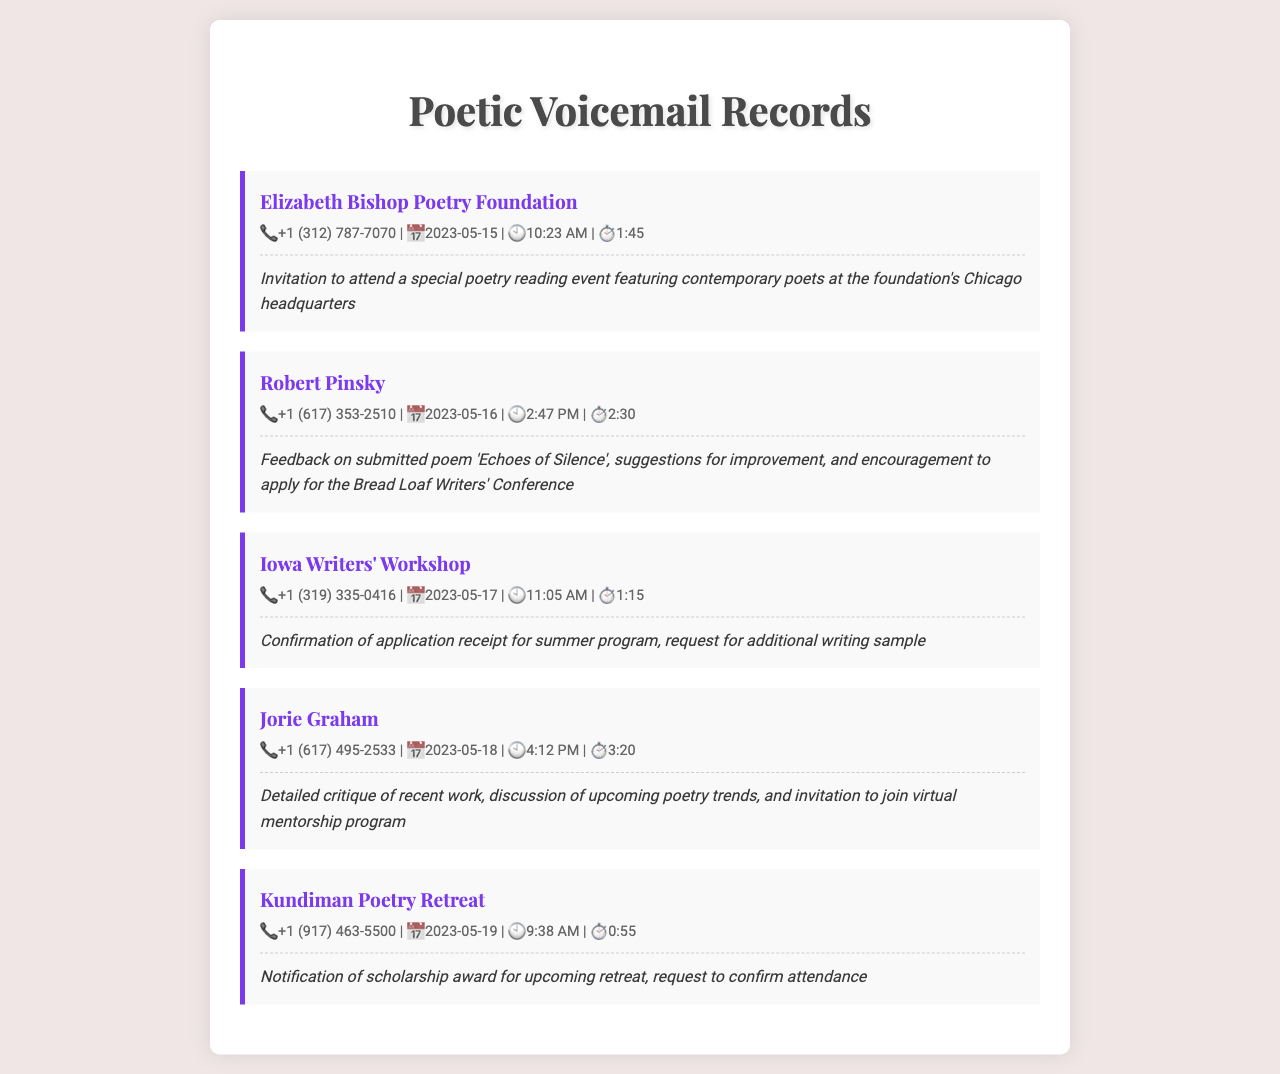What is the caller's name from the Elizabeth Bishop Poetry Foundation? The caller's name is clearly indicated in the record as "Elizabeth Bishop Poetry Foundation."
Answer: Elizabeth Bishop Poetry Foundation What was the date of Robert Pinsky's voicemail? The date can be found in the details section of Robert Pinsky's record, highlighting when the message was received.
Answer: 2023-05-16 How long was Jorie Graham's voicemail message? The duration of Jorie Graham's voicemail is listed in her message details, which provides the length of the recorded message.
Answer: 3:20 What invitation did the Iowa Writers' Workshop extend? The summary of the Iowa Writers' Workshop message details that a confirmation of application receipt was provided along with a request for additional writing sample.
Answer: Request for additional writing sample Who received a scholarship notification from Kundiman Poetry Retreat? The caller is specified in the record regarding whom the message is intended for, indicating a positive acknowledgment regarding the scholarship.
Answer: Kundiman Poetry Retreat What time was the voicemail from the Iowa Writers' Workshop received? The time of the voicemail is noted in the details of the Iowa Writers' Workshop record, indicating when the message was left.
Answer: 11:05 AM What kind of message did Jorie Graham provide? The summary of Jorie Graham specifies the kind of feedback given, focusing on details regarding critique and trends.
Answer: Detailed critique of recent work Which caller provided feedback on 'Echoes of Silence'? The summary of Robert Pinsky's voicemail confirms he is the individual providing feedback on the specific poem titled.
Answer: Robert Pinsky 